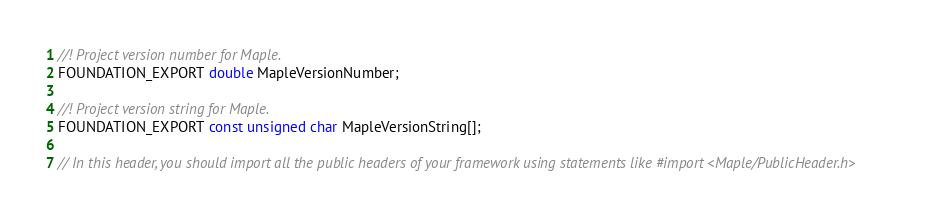<code> <loc_0><loc_0><loc_500><loc_500><_C_>//! Project version number for Maple.
FOUNDATION_EXPORT double MapleVersionNumber;

//! Project version string for Maple.
FOUNDATION_EXPORT const unsigned char MapleVersionString[];

// In this header, you should import all the public headers of your framework using statements like #import <Maple/PublicHeader.h>


</code> 